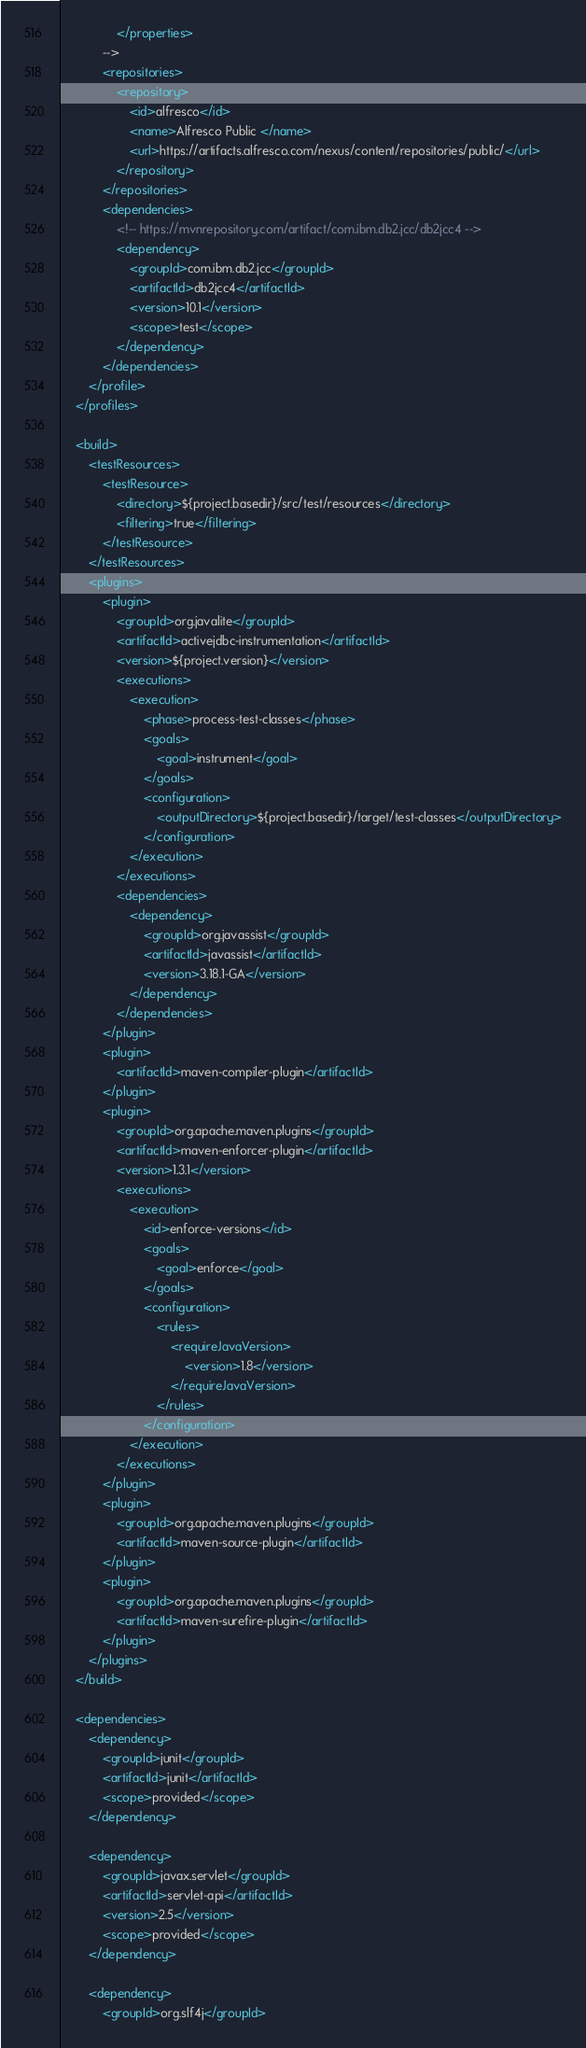Convert code to text. <code><loc_0><loc_0><loc_500><loc_500><_XML_>                </properties>
			-->
			<repositories>
				<repository>
					<id>alfresco</id>
					<name>Alfresco Public </name>
					<url>https://artifacts.alfresco.com/nexus/content/repositories/public/</url>
				</repository>
			</repositories>
			<dependencies>
				<!-- https://mvnrepository.com/artifact/com.ibm.db2.jcc/db2jcc4 -->
				<dependency>
					<groupId>com.ibm.db2.jcc</groupId>
					<artifactId>db2jcc4</artifactId>
					<version>10.1</version>
					<scope>test</scope>
				</dependency>
			</dependencies>
		</profile>
    </profiles>

    <build>
        <testResources>
            <testResource>
                <directory>${project.basedir}/src/test/resources</directory>
                <filtering>true</filtering>
            </testResource>
        </testResources>
        <plugins>
            <plugin>
                <groupId>org.javalite</groupId>
                <artifactId>activejdbc-instrumentation</artifactId>
                <version>${project.version}</version>
                <executions>
                    <execution>
                        <phase>process-test-classes</phase>
                        <goals>
                            <goal>instrument</goal>
                        </goals>
                        <configuration>
                            <outputDirectory>${project.basedir}/target/test-classes</outputDirectory>
                        </configuration>
                    </execution>
                </executions>
                <dependencies>
                    <dependency>
                        <groupId>org.javassist</groupId>
                        <artifactId>javassist</artifactId>
                        <version>3.18.1-GA</version>
                    </dependency>
                </dependencies>
            </plugin>
            <plugin>
                <artifactId>maven-compiler-plugin</artifactId>
            </plugin>
            <plugin>
                <groupId>org.apache.maven.plugins</groupId>
                <artifactId>maven-enforcer-plugin</artifactId>
                <version>1.3.1</version>
                <executions>
                    <execution>
                        <id>enforce-versions</id>
                        <goals>
                            <goal>enforce</goal>
                        </goals>
                        <configuration>
                            <rules>
                                <requireJavaVersion>
                                    <version>1.8</version>
                                </requireJavaVersion>
                            </rules>
                        </configuration>
                    </execution>
                </executions>
            </plugin>
            <plugin>
                <groupId>org.apache.maven.plugins</groupId>
                <artifactId>maven-source-plugin</artifactId>
            </plugin>
            <plugin>
                <groupId>org.apache.maven.plugins</groupId>
                <artifactId>maven-surefire-plugin</artifactId>
            </plugin>
        </plugins>
    </build>

    <dependencies>
        <dependency>
            <groupId>junit</groupId>
            <artifactId>junit</artifactId>
            <scope>provided</scope>
        </dependency>

        <dependency>
            <groupId>javax.servlet</groupId>
            <artifactId>servlet-api</artifactId>
            <version>2.5</version>
            <scope>provided</scope>
        </dependency>

        <dependency>
            <groupId>org.slf4j</groupId></code> 